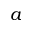Convert formula to latex. <formula><loc_0><loc_0><loc_500><loc_500>a</formula> 